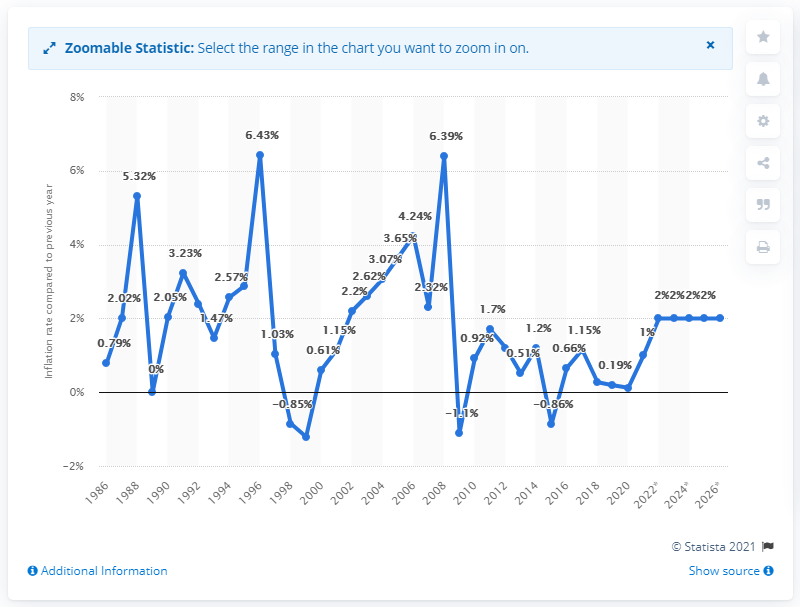Point out several critical features in this image. The inflation rate in Belize in 2020 was 0.12%. 